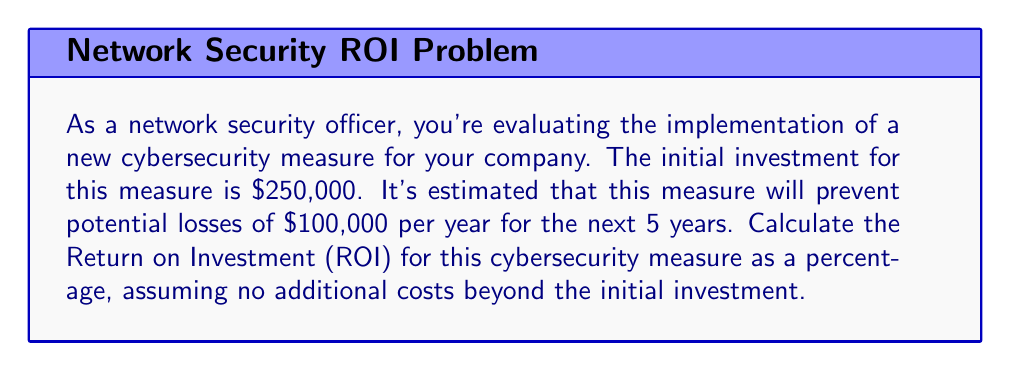Help me with this question. To solve this problem, we'll follow these steps:

1. Calculate the total benefits over 5 years
2. Calculate the net profit (total benefits minus initial investment)
3. Use the ROI formula to calculate the percentage return

Step 1: Calculate total benefits
The measure prevents losses of $100,000 per year for 5 years.
Total benefits = $100,000 × 5 = $500,000

Step 2: Calculate net profit
Net profit = Total benefits - Initial investment
Net profit = $500,000 - $250,000 = $250,000

Step 3: Calculate ROI
The ROI formula is:

$$ ROI = \frac{\text{Net Profit}}{\text{Initial Investment}} \times 100\% $$

Plugging in our values:

$$ ROI = \frac{\$250,000}{\$250,000} \times 100\% $$

$$ ROI = 1 \times 100\% = 100\% $$

Therefore, the Return on Investment for this cybersecurity measure is 100%.
Answer: 100% 